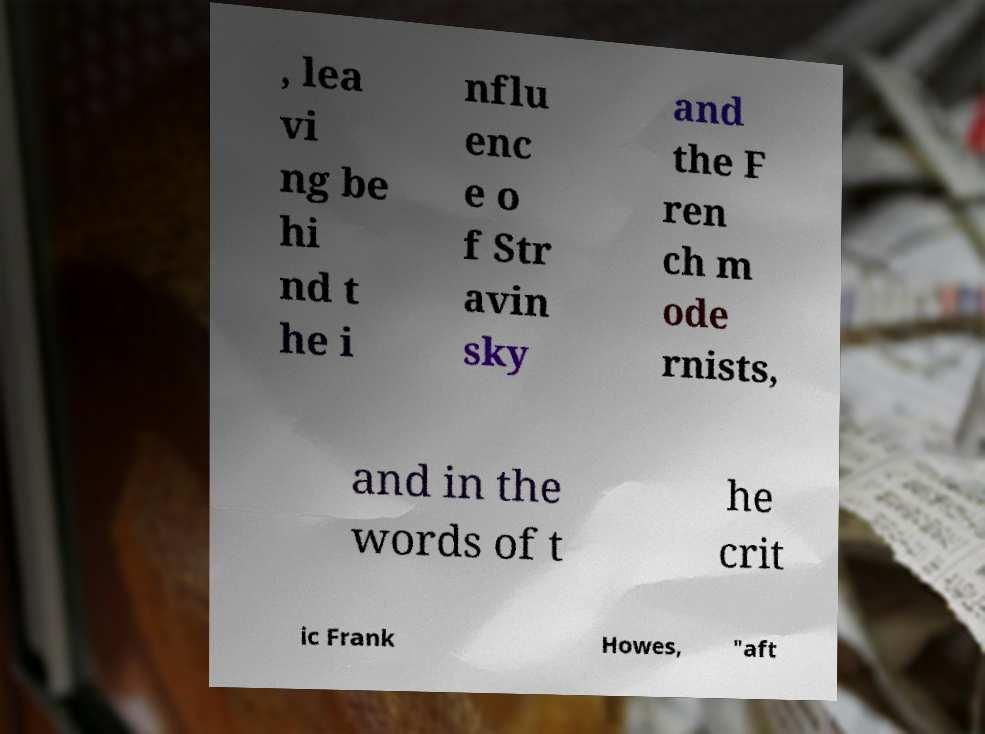I need the written content from this picture converted into text. Can you do that? , lea vi ng be hi nd t he i nflu enc e o f Str avin sky and the F ren ch m ode rnists, and in the words of t he crit ic Frank Howes, "aft 